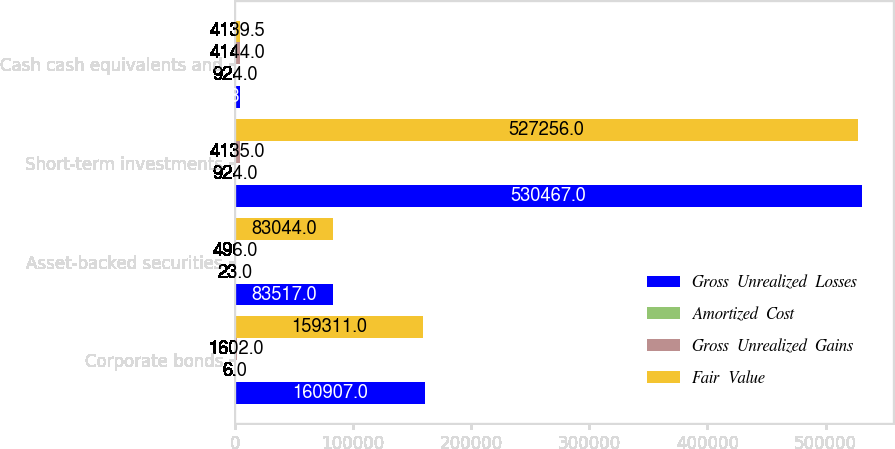Convert chart. <chart><loc_0><loc_0><loc_500><loc_500><stacked_bar_chart><ecel><fcel>Corporate bonds<fcel>Asset-backed securities<fcel>Short-term investments<fcel>Cash cash equivalents and<nl><fcel>Gross  Unrealized  Losses<fcel>160907<fcel>83517<fcel>530467<fcel>4139.5<nl><fcel>Amortized  Cost<fcel>6<fcel>23<fcel>924<fcel>924<nl><fcel>Gross  Unrealized  Gains<fcel>1602<fcel>496<fcel>4135<fcel>4144<nl><fcel>Fair  Value<fcel>159311<fcel>83044<fcel>527256<fcel>4139.5<nl></chart> 